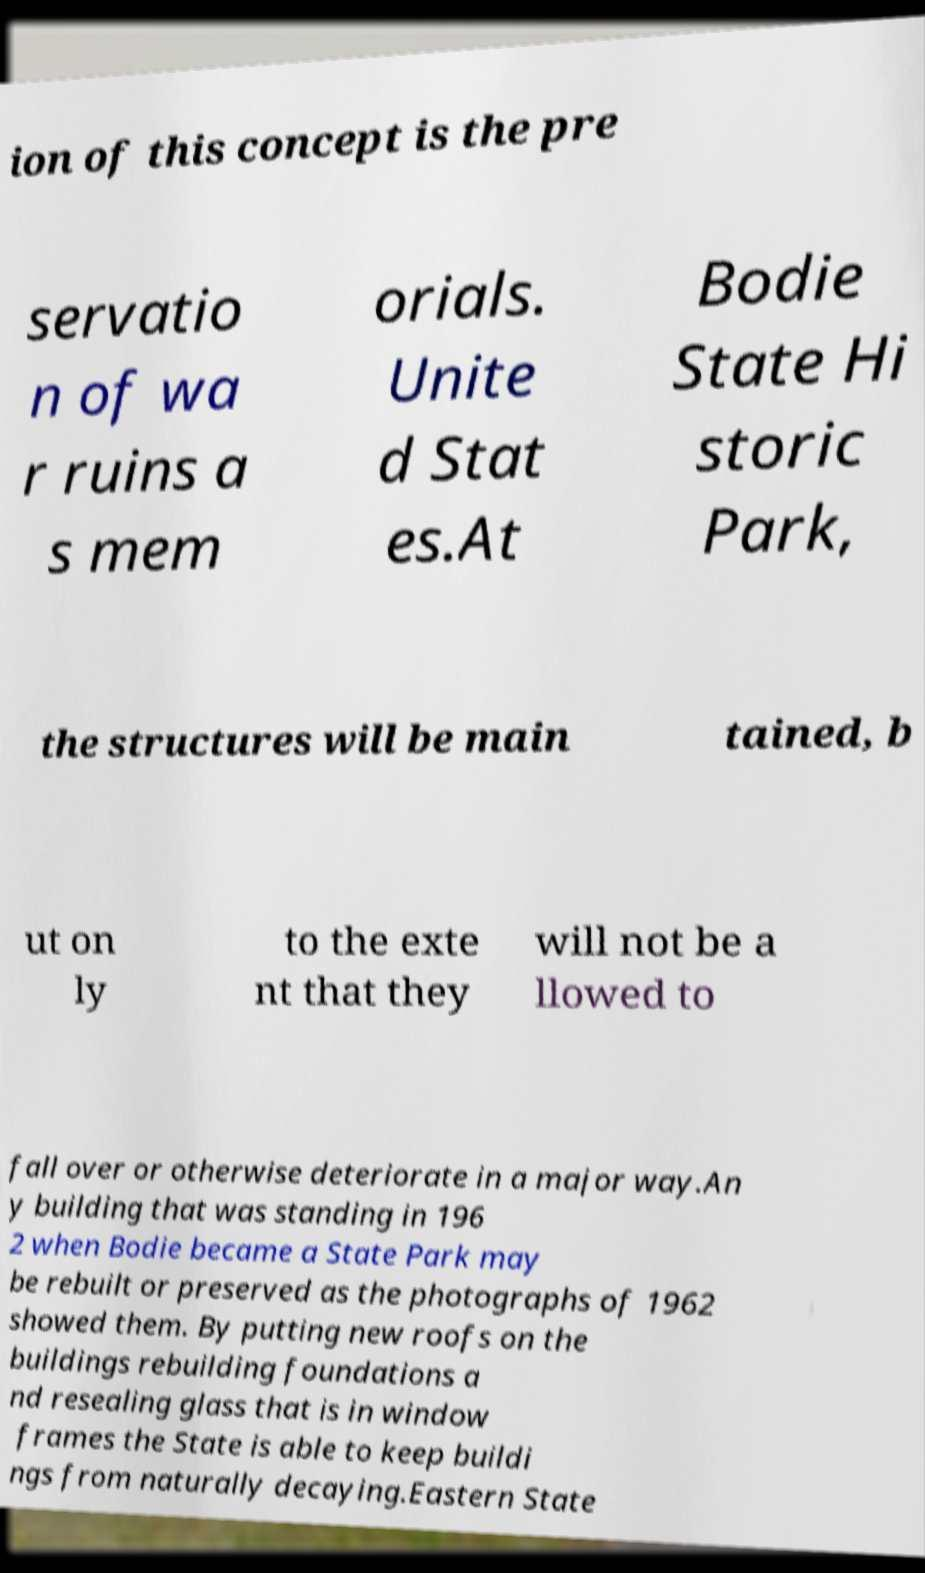Please identify and transcribe the text found in this image. ion of this concept is the pre servatio n of wa r ruins a s mem orials. Unite d Stat es.At Bodie State Hi storic Park, the structures will be main tained, b ut on ly to the exte nt that they will not be a llowed to fall over or otherwise deteriorate in a major way.An y building that was standing in 196 2 when Bodie became a State Park may be rebuilt or preserved as the photographs of 1962 showed them. By putting new roofs on the buildings rebuilding foundations a nd resealing glass that is in window frames the State is able to keep buildi ngs from naturally decaying.Eastern State 